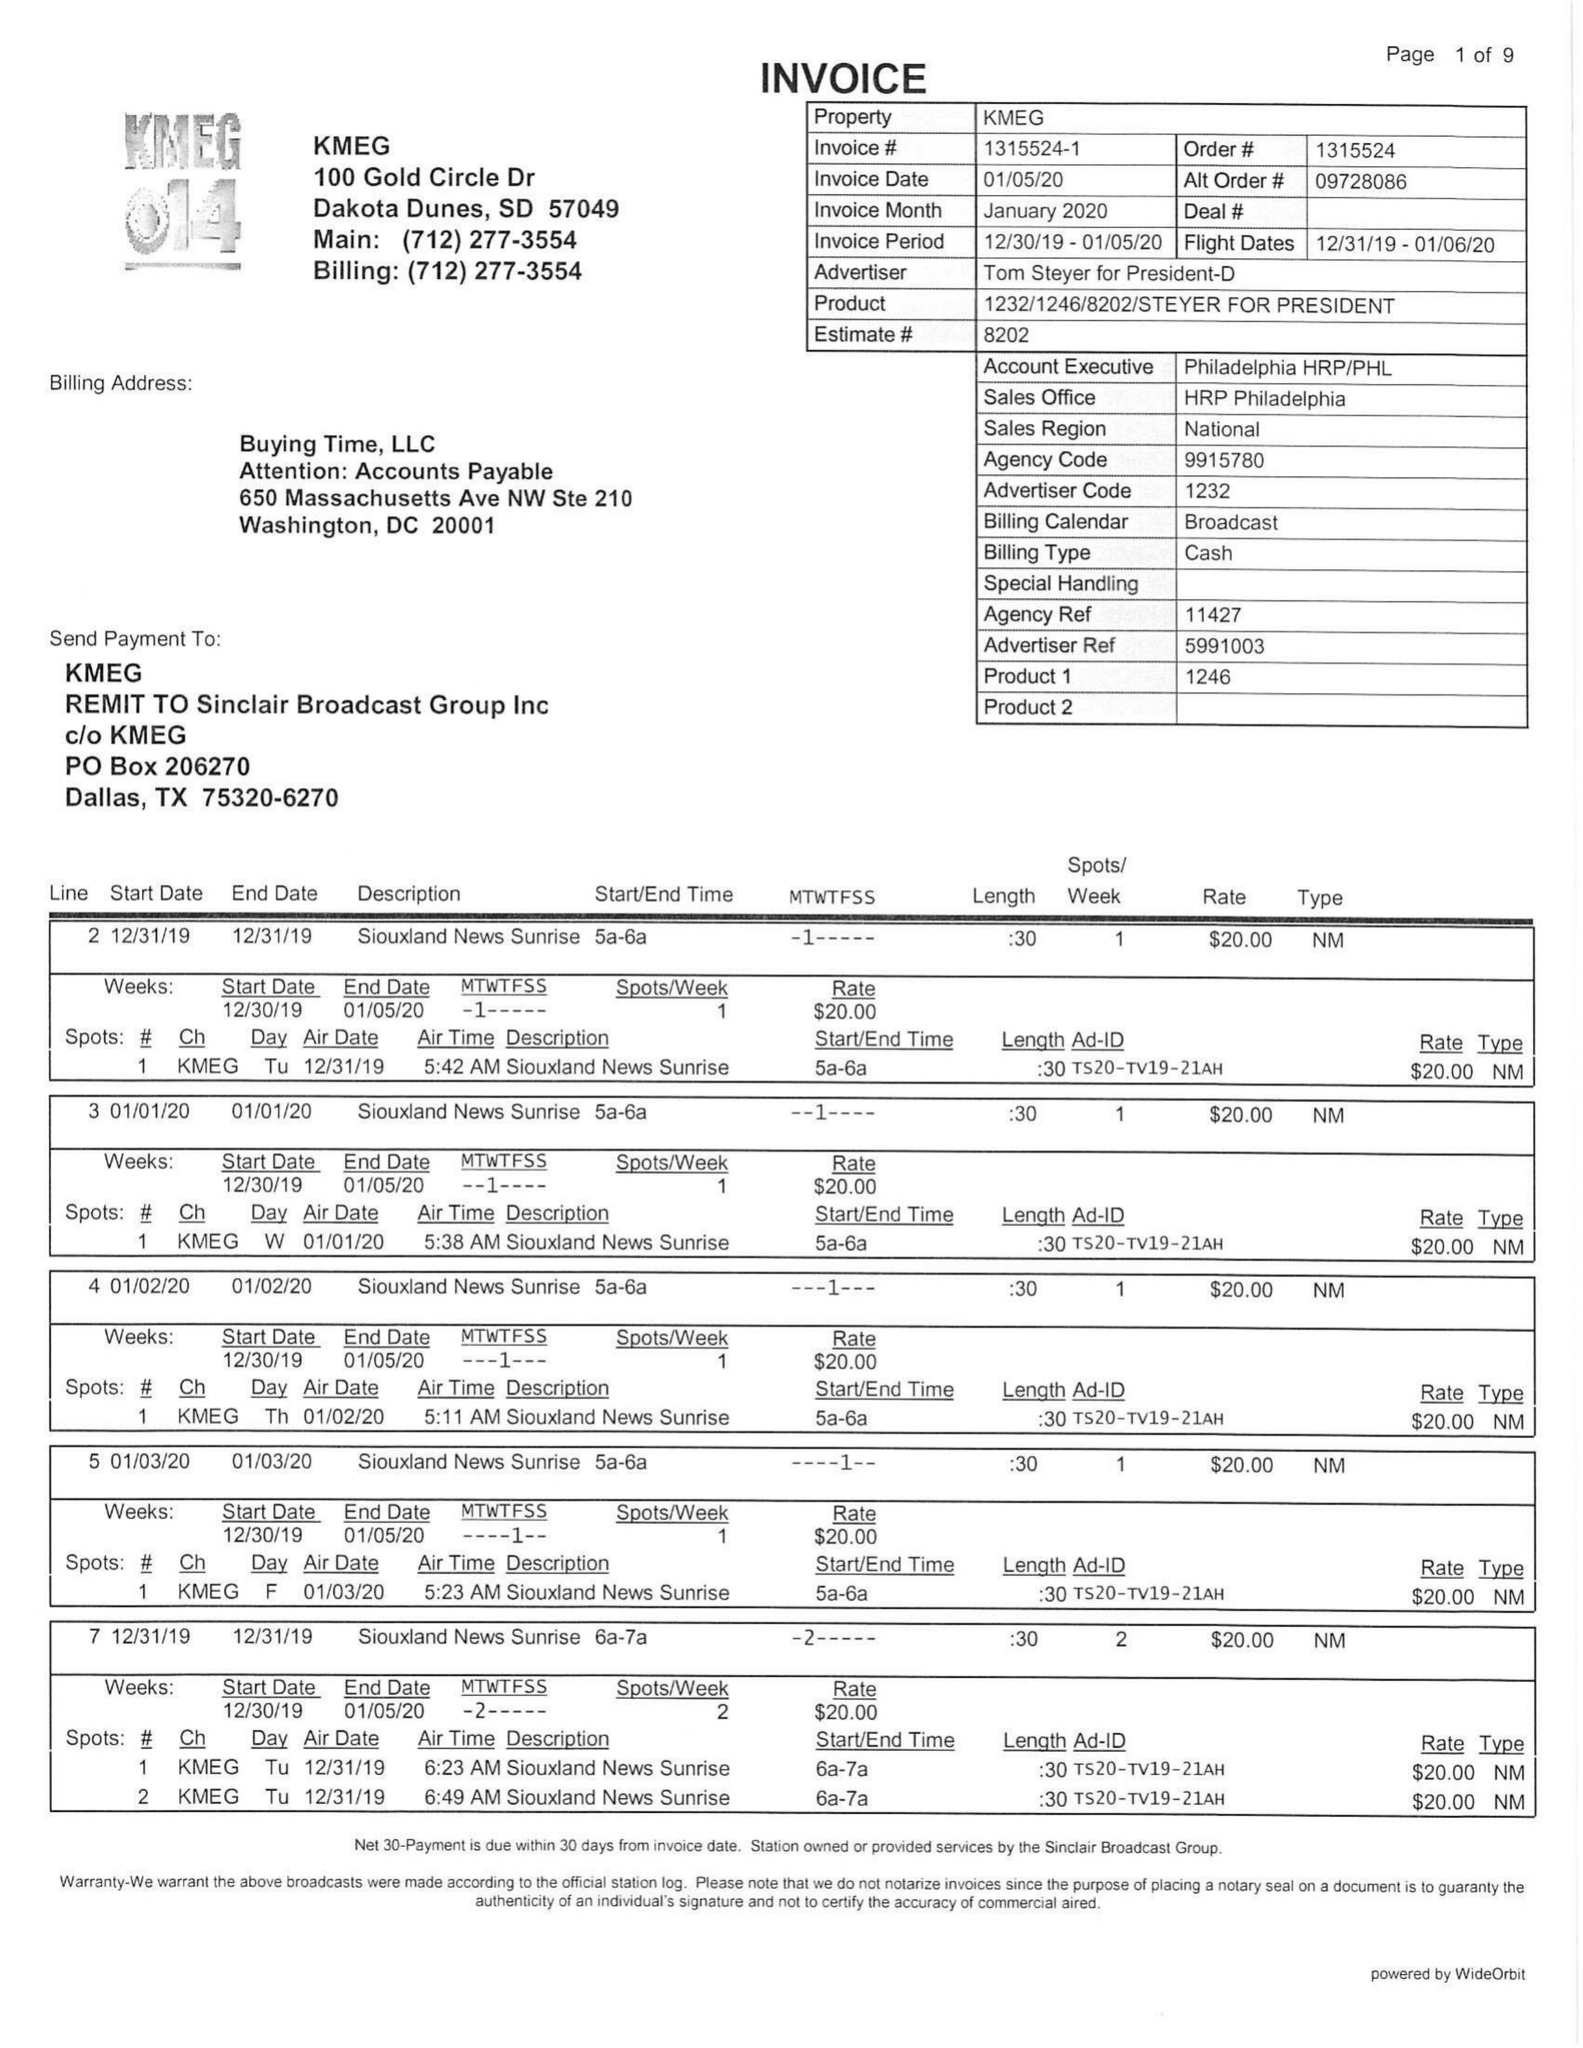What is the value for the flight_to?
Answer the question using a single word or phrase. 01/06/20 